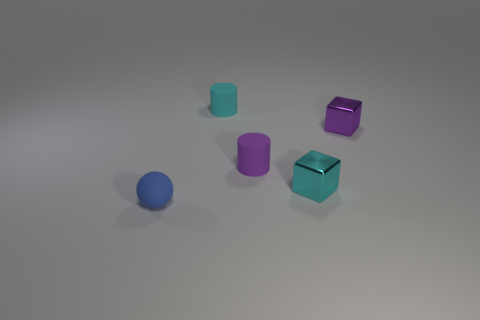Add 1 tiny cyan matte things. How many objects exist? 6 Subtract all cubes. How many objects are left? 3 Subtract all small gray objects. Subtract all small blue spheres. How many objects are left? 4 Add 2 tiny things. How many tiny things are left? 7 Add 2 purple cylinders. How many purple cylinders exist? 3 Subtract 1 cyan cylinders. How many objects are left? 4 